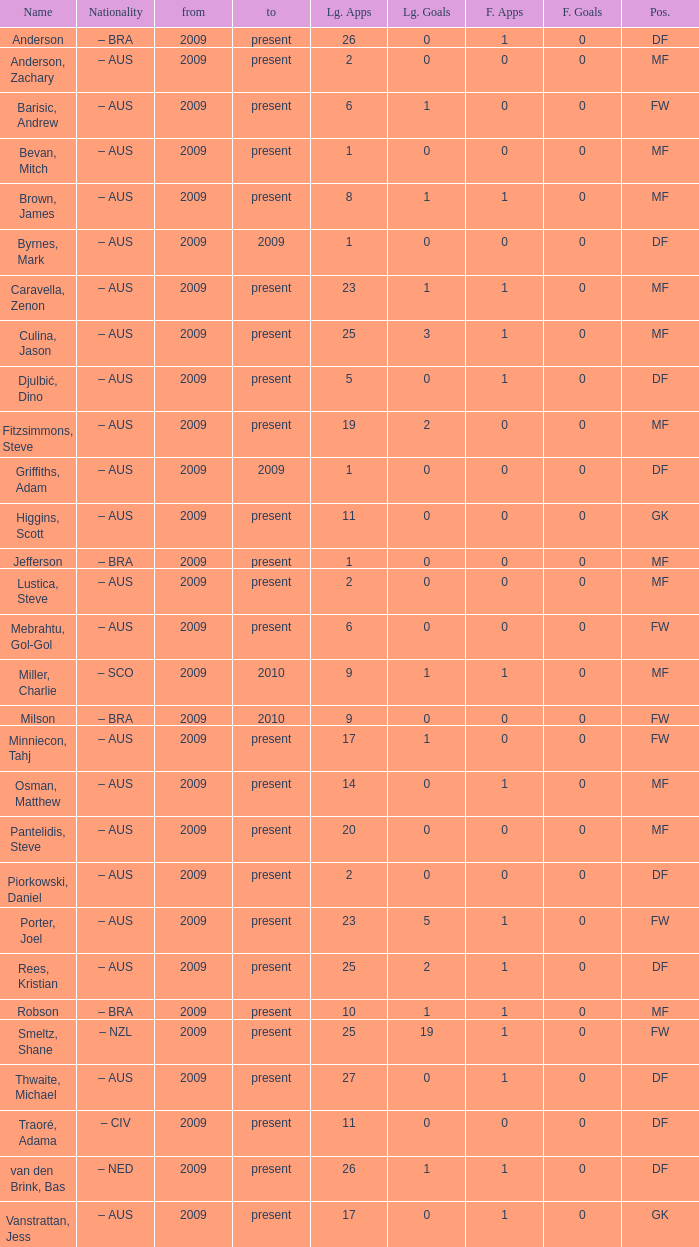Name the to for 19 league apps Present. 